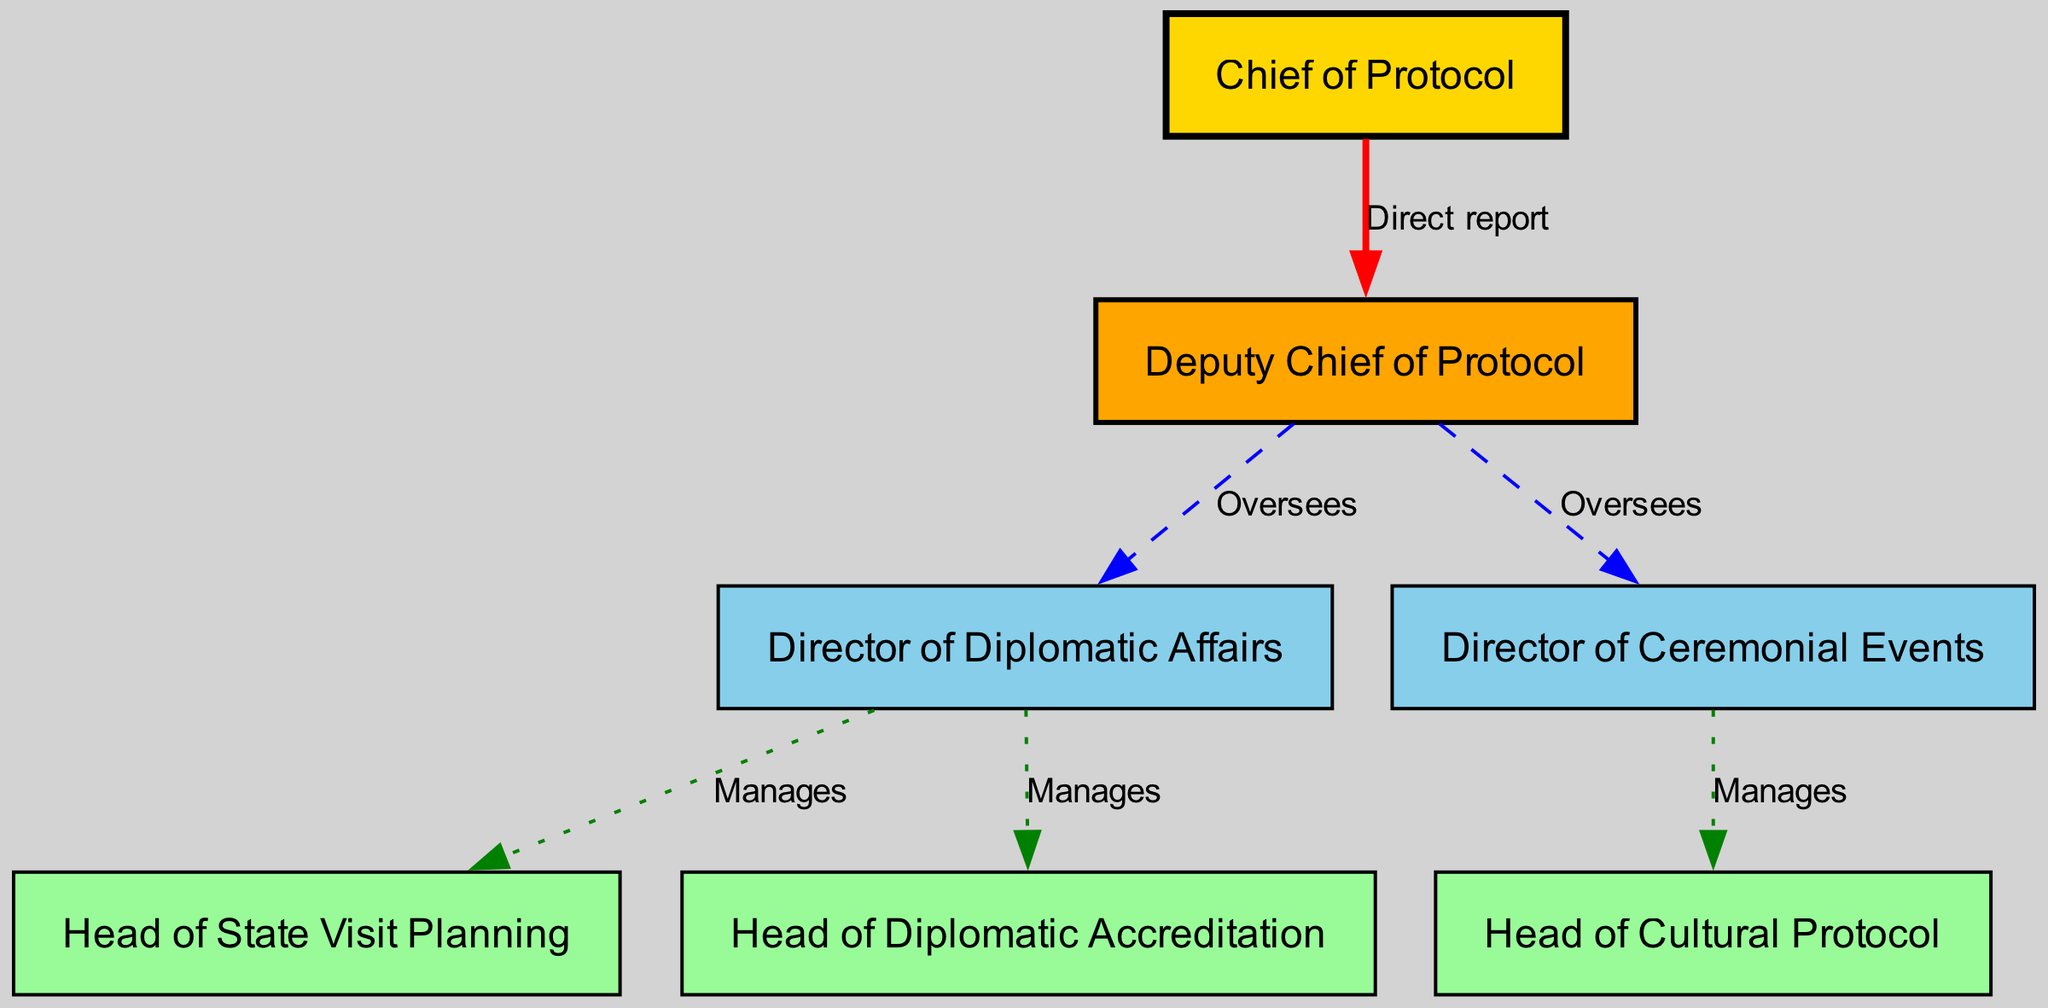What is the highest position in the organizational structure? The diagram identifies the "Chief of Protocol" as the highest position, represented by the top node in the structure with direct reports underneath it.
Answer: Chief of Protocol How many total nodes are represented in the diagram? Counting all the labeled roles within the organizational structure, there are eight nodes including the Chief of Protocol and its direct and indirect reports.
Answer: 7 Who directly reports to the Deputy Chief of Protocol? The diagram shows that both the "Director of Diplomatic Affairs" and the "Director of Ceremonial Events" have a line connecting them to the "Deputy Chief of Protocol", indicating they both report to this role.
Answer: Director of Diplomatic Affairs, Director of Ceremonial Events How many roles report directly to the Chief of Protocol? The diagram indicates that only one role, the "Deputy Chief of Protocol," has a direct reporting line to the Chief of Protocol, which is visually represented with a solid edge labeled as "Direct report."
Answer: 1 Which role manages the Head of Cultural Protocol? The "Director of Ceremonial Events" manages the Head of Cultural Protocol, as indicated by the diagram's managing relationship represented with a dashed edge connecting them.
Answer: Director of Ceremonial Events Which two roles does the Deputy Chief of Protocol oversee? According to the diagram, the Deputy Chief of Protocol oversees both the "Director of Diplomatic Affairs" and the "Director of Ceremonial Events," shown by the dashed lines connecting them.
Answer: Director of Diplomatic Affairs, Director of Ceremonial Events What type of relationship is depicted between the Director of Diplomatic Affairs and the Head of State Visit Planning? The relationship between these two roles is represented in the diagram as a "Manages" relationship, indicating that the Director of Diplomatic Affairs oversees the Head of State Visit Planning.
Answer: Manages How many "Oversees" type relationships are present in the diagram? There are three "Oversees" relationships in the diagram, as indicated by the dashed lines, which connect the Deputy Chief of Protocol to both the Director of Diplomatic Affairs and Director of Ceremonial Events.
Answer: 2 Which position is responsible for managing the Head of Diplomatic Accreditation? The "Director of Diplomatic Affairs" is responsible for managing the Head of Diplomatic Accreditation, as shown by the managing edge labeled "Manages" connecting them in the diagram.
Answer: Director of Diplomatic Affairs 